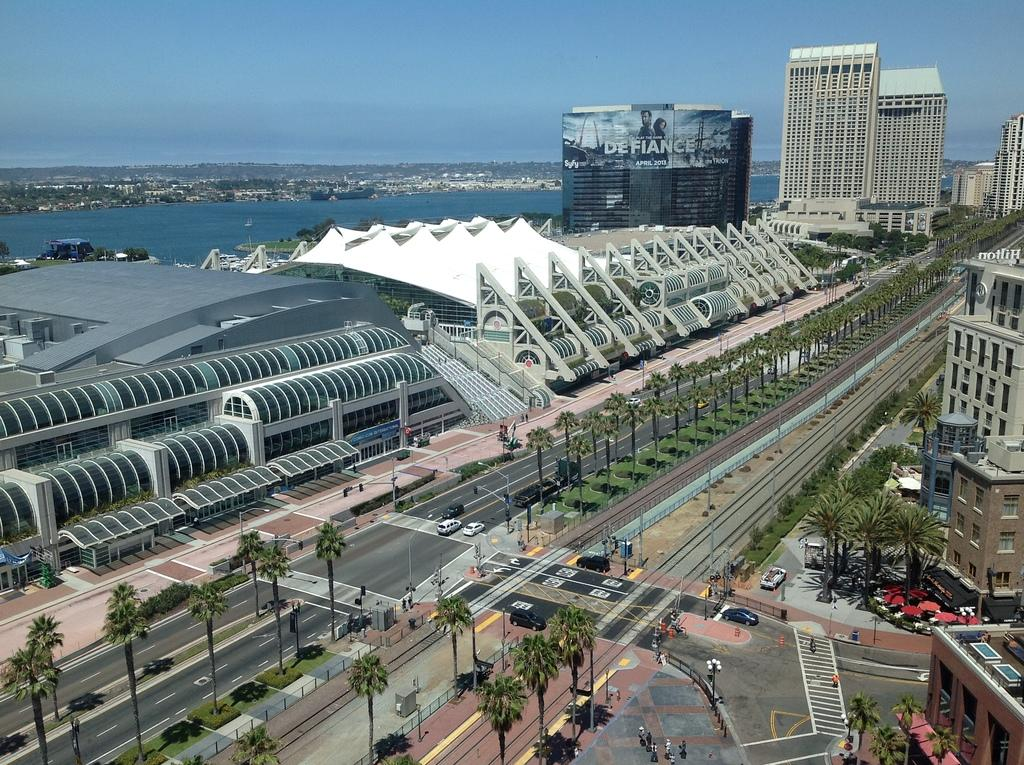What type of structures can be seen in the image? There are buildings in the image. What natural elements are present in the image? There are trees and grass visible in the image. What type of transportation can be seen in the image? There are vehicles on the road in the image. Are there any people visible in the image? Yes, there are people on the pavements in the image. What body of water can be seen in the image? There is water visible in the image. What part of the natural environment is visible in the image? The sky is visible in the image. What type of teeth can be seen in the image? There are no teeth visible in the image. Is there a camera present in the image? There is no camera visible in the image. 